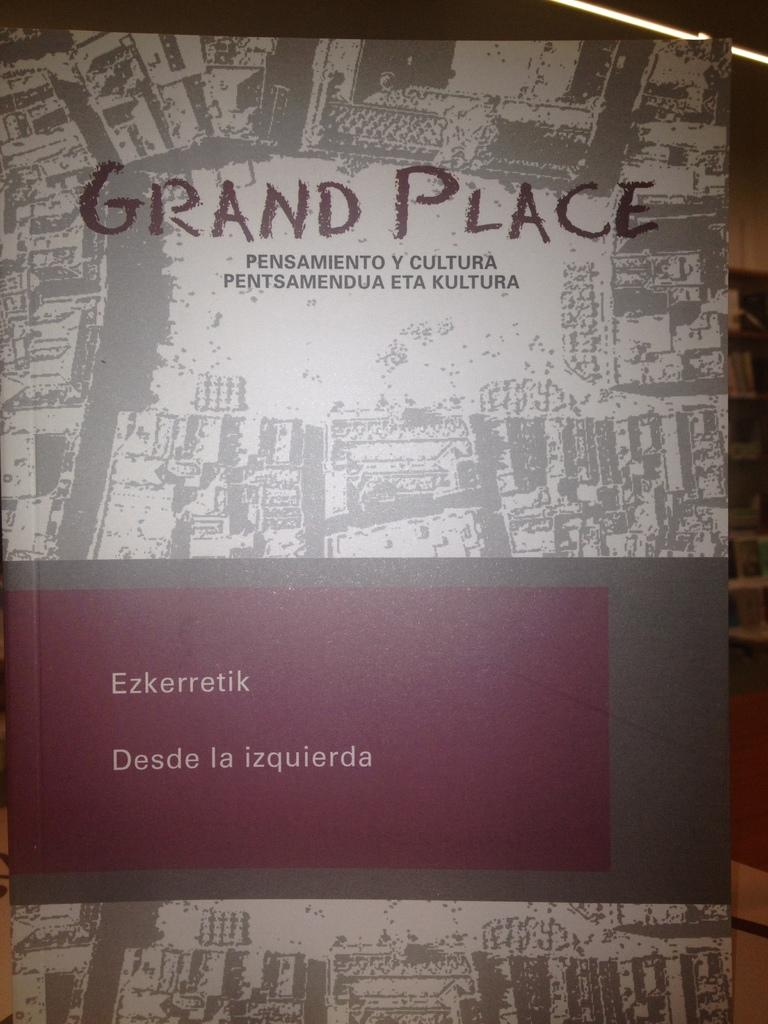<image>
Render a clear and concise summary of the photo. The book titled Grand Place has been kept in very good condition. 